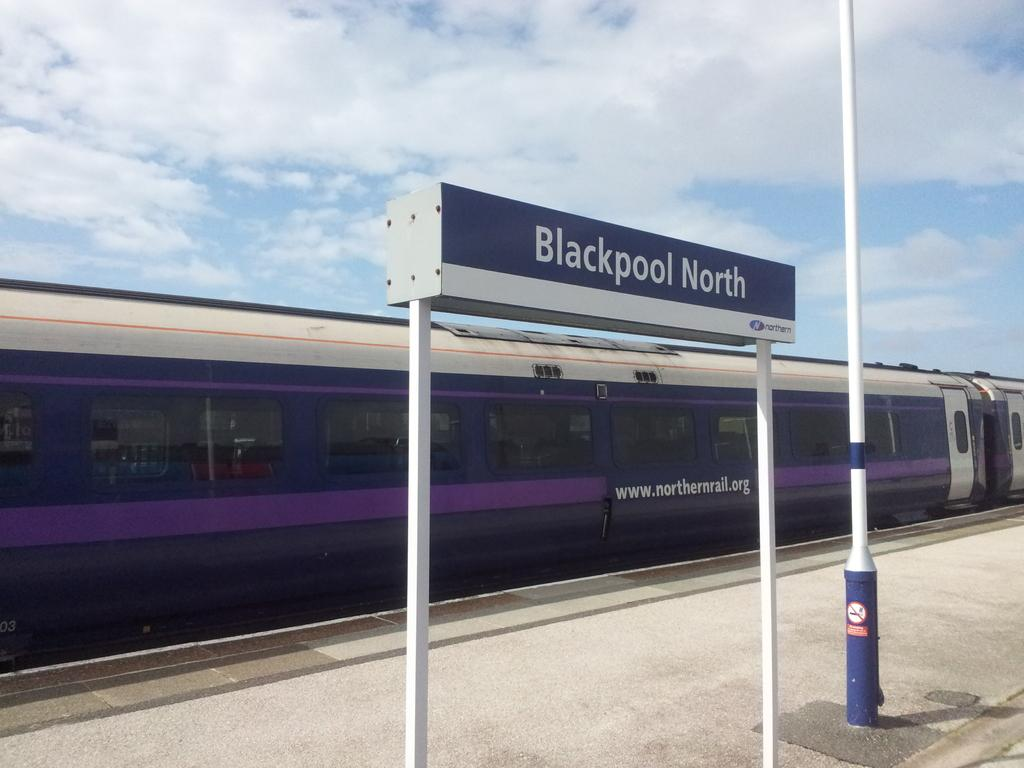What is the main subject of focus of the image? The main focus of the image is a locomotive. What is located near the locomotive? There is a platform in the image. What can be seen on the platform? There is a name board in the image. What else is present in the image besides the locomotive and platform? There is a pole in the image. What is visible in the background of the image? The sky is visible in the image, and clouds are present in the sky. What type of alley can be seen behind the locomotive in the image? There is no alley present in the image; it features a locomotive, platform, name board, pole, and sky with clouds. 